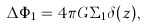Convert formula to latex. <formula><loc_0><loc_0><loc_500><loc_500>\Delta \Phi _ { 1 } = 4 \pi G \Sigma _ { 1 } \delta ( z ) ,</formula> 